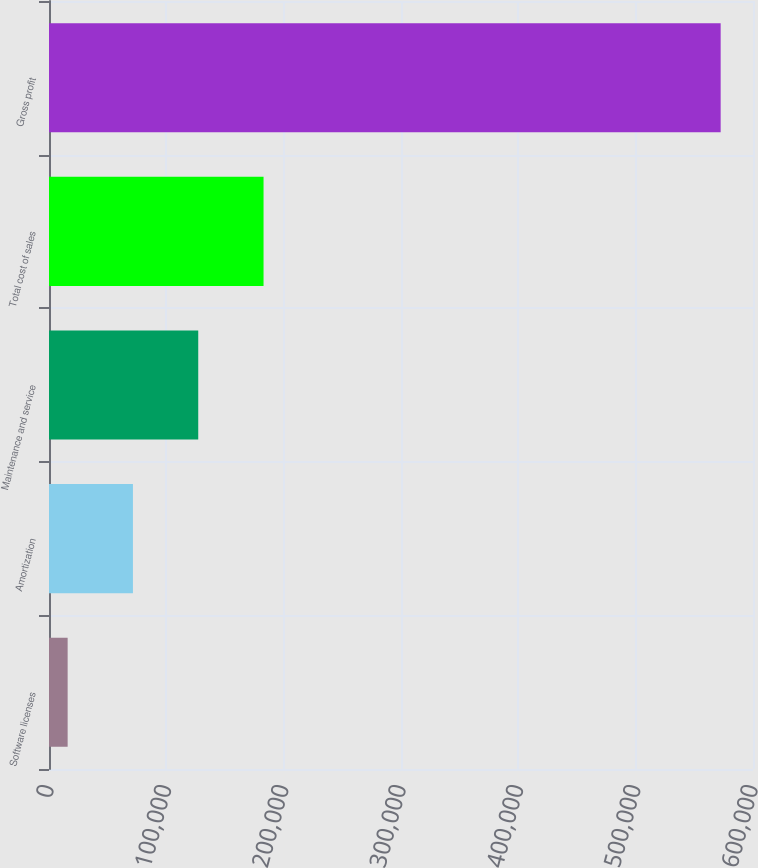Convert chart. <chart><loc_0><loc_0><loc_500><loc_500><bar_chart><fcel>Software licenses<fcel>Amortization<fcel>Maintenance and service<fcel>Total cost of sales<fcel>Gross profit<nl><fcel>15884<fcel>71539.1<fcel>127194<fcel>182849<fcel>572435<nl></chart> 